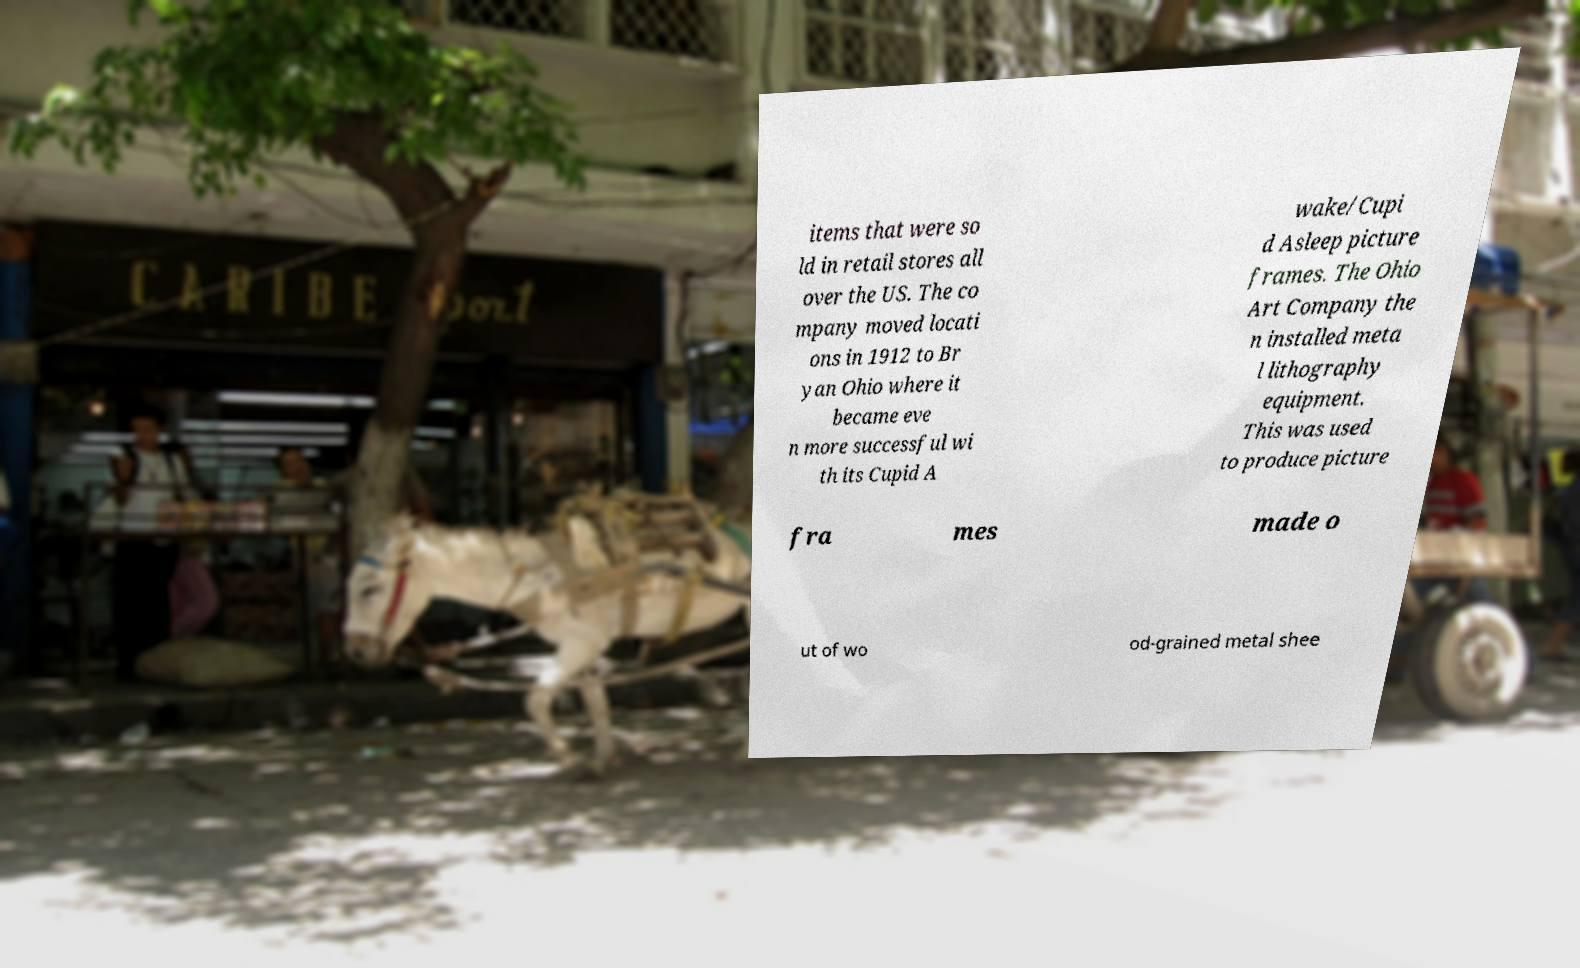Please identify and transcribe the text found in this image. items that were so ld in retail stores all over the US. The co mpany moved locati ons in 1912 to Br yan Ohio where it became eve n more successful wi th its Cupid A wake/Cupi d Asleep picture frames. The Ohio Art Company the n installed meta l lithography equipment. This was used to produce picture fra mes made o ut of wo od-grained metal shee 